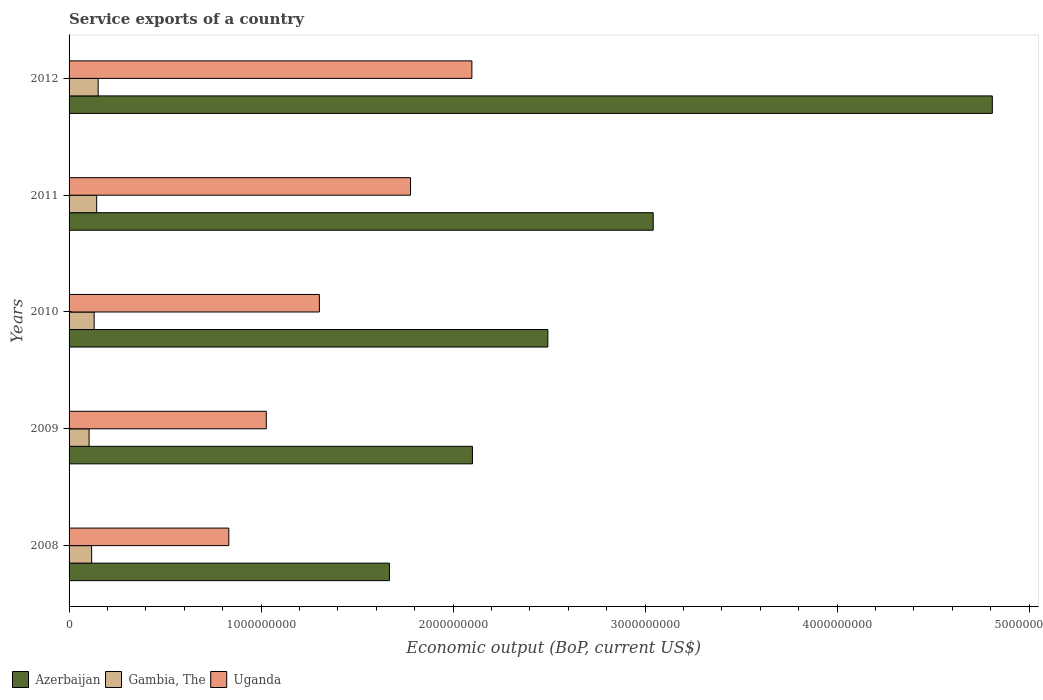How many groups of bars are there?
Provide a short and direct response. 5. Are the number of bars per tick equal to the number of legend labels?
Provide a short and direct response. Yes. Are the number of bars on each tick of the Y-axis equal?
Your answer should be compact. Yes. How many bars are there on the 2nd tick from the bottom?
Your answer should be very brief. 3. In how many cases, is the number of bars for a given year not equal to the number of legend labels?
Your answer should be very brief. 0. What is the service exports in Uganda in 2012?
Keep it short and to the point. 2.10e+09. Across all years, what is the maximum service exports in Uganda?
Provide a succinct answer. 2.10e+09. Across all years, what is the minimum service exports in Uganda?
Your answer should be compact. 8.32e+08. In which year was the service exports in Gambia, The maximum?
Your answer should be very brief. 2012. What is the total service exports in Azerbaijan in the graph?
Provide a succinct answer. 1.41e+1. What is the difference between the service exports in Gambia, The in 2010 and that in 2012?
Offer a very short reply. -2.08e+07. What is the difference between the service exports in Azerbaijan in 2011 and the service exports in Gambia, The in 2008?
Your answer should be very brief. 2.92e+09. What is the average service exports in Azerbaijan per year?
Your response must be concise. 2.82e+09. In the year 2010, what is the difference between the service exports in Gambia, The and service exports in Uganda?
Your response must be concise. -1.17e+09. What is the ratio of the service exports in Gambia, The in 2010 to that in 2012?
Offer a terse response. 0.86. What is the difference between the highest and the second highest service exports in Uganda?
Make the answer very short. 3.20e+08. What is the difference between the highest and the lowest service exports in Azerbaijan?
Give a very brief answer. 3.14e+09. In how many years, is the service exports in Uganda greater than the average service exports in Uganda taken over all years?
Give a very brief answer. 2. Is the sum of the service exports in Gambia, The in 2008 and 2011 greater than the maximum service exports in Azerbaijan across all years?
Offer a very short reply. No. What does the 1st bar from the top in 2009 represents?
Your answer should be very brief. Uganda. What does the 2nd bar from the bottom in 2012 represents?
Give a very brief answer. Gambia, The. How many bars are there?
Offer a very short reply. 15. Are all the bars in the graph horizontal?
Offer a very short reply. Yes. Are the values on the major ticks of X-axis written in scientific E-notation?
Ensure brevity in your answer.  No. Does the graph contain any zero values?
Offer a very short reply. No. How many legend labels are there?
Offer a terse response. 3. How are the legend labels stacked?
Make the answer very short. Horizontal. What is the title of the graph?
Give a very brief answer. Service exports of a country. What is the label or title of the X-axis?
Offer a very short reply. Economic output (BoP, current US$). What is the Economic output (BoP, current US$) of Azerbaijan in 2008?
Give a very brief answer. 1.67e+09. What is the Economic output (BoP, current US$) in Gambia, The in 2008?
Provide a succinct answer. 1.18e+08. What is the Economic output (BoP, current US$) of Uganda in 2008?
Offer a terse response. 8.32e+08. What is the Economic output (BoP, current US$) in Azerbaijan in 2009?
Give a very brief answer. 2.10e+09. What is the Economic output (BoP, current US$) of Gambia, The in 2009?
Keep it short and to the point. 1.04e+08. What is the Economic output (BoP, current US$) of Uganda in 2009?
Provide a succinct answer. 1.03e+09. What is the Economic output (BoP, current US$) of Azerbaijan in 2010?
Keep it short and to the point. 2.49e+09. What is the Economic output (BoP, current US$) in Gambia, The in 2010?
Keep it short and to the point. 1.31e+08. What is the Economic output (BoP, current US$) of Uganda in 2010?
Keep it short and to the point. 1.30e+09. What is the Economic output (BoP, current US$) of Azerbaijan in 2011?
Your response must be concise. 3.04e+09. What is the Economic output (BoP, current US$) in Gambia, The in 2011?
Give a very brief answer. 1.44e+08. What is the Economic output (BoP, current US$) in Uganda in 2011?
Offer a very short reply. 1.78e+09. What is the Economic output (BoP, current US$) of Azerbaijan in 2012?
Offer a terse response. 4.81e+09. What is the Economic output (BoP, current US$) of Gambia, The in 2012?
Make the answer very short. 1.51e+08. What is the Economic output (BoP, current US$) of Uganda in 2012?
Make the answer very short. 2.10e+09. Across all years, what is the maximum Economic output (BoP, current US$) of Azerbaijan?
Ensure brevity in your answer.  4.81e+09. Across all years, what is the maximum Economic output (BoP, current US$) of Gambia, The?
Offer a very short reply. 1.51e+08. Across all years, what is the maximum Economic output (BoP, current US$) of Uganda?
Make the answer very short. 2.10e+09. Across all years, what is the minimum Economic output (BoP, current US$) of Azerbaijan?
Your answer should be compact. 1.67e+09. Across all years, what is the minimum Economic output (BoP, current US$) of Gambia, The?
Provide a short and direct response. 1.04e+08. Across all years, what is the minimum Economic output (BoP, current US$) in Uganda?
Your answer should be compact. 8.32e+08. What is the total Economic output (BoP, current US$) in Azerbaijan in the graph?
Offer a terse response. 1.41e+1. What is the total Economic output (BoP, current US$) of Gambia, The in the graph?
Keep it short and to the point. 6.48e+08. What is the total Economic output (BoP, current US$) in Uganda in the graph?
Your answer should be compact. 7.04e+09. What is the difference between the Economic output (BoP, current US$) of Azerbaijan in 2008 and that in 2009?
Provide a succinct answer. -4.32e+08. What is the difference between the Economic output (BoP, current US$) of Gambia, The in 2008 and that in 2009?
Ensure brevity in your answer.  1.34e+07. What is the difference between the Economic output (BoP, current US$) in Uganda in 2008 and that in 2009?
Provide a succinct answer. -1.95e+08. What is the difference between the Economic output (BoP, current US$) of Azerbaijan in 2008 and that in 2010?
Give a very brief answer. -8.25e+08. What is the difference between the Economic output (BoP, current US$) of Gambia, The in 2008 and that in 2010?
Make the answer very short. -1.31e+07. What is the difference between the Economic output (BoP, current US$) in Uganda in 2008 and that in 2010?
Provide a short and direct response. -4.72e+08. What is the difference between the Economic output (BoP, current US$) of Azerbaijan in 2008 and that in 2011?
Ensure brevity in your answer.  -1.37e+09. What is the difference between the Economic output (BoP, current US$) of Gambia, The in 2008 and that in 2011?
Ensure brevity in your answer.  -2.62e+07. What is the difference between the Economic output (BoP, current US$) of Uganda in 2008 and that in 2011?
Offer a very short reply. -9.46e+08. What is the difference between the Economic output (BoP, current US$) in Azerbaijan in 2008 and that in 2012?
Give a very brief answer. -3.14e+09. What is the difference between the Economic output (BoP, current US$) of Gambia, The in 2008 and that in 2012?
Keep it short and to the point. -3.39e+07. What is the difference between the Economic output (BoP, current US$) in Uganda in 2008 and that in 2012?
Make the answer very short. -1.27e+09. What is the difference between the Economic output (BoP, current US$) in Azerbaijan in 2009 and that in 2010?
Give a very brief answer. -3.93e+08. What is the difference between the Economic output (BoP, current US$) of Gambia, The in 2009 and that in 2010?
Offer a very short reply. -2.65e+07. What is the difference between the Economic output (BoP, current US$) of Uganda in 2009 and that in 2010?
Make the answer very short. -2.76e+08. What is the difference between the Economic output (BoP, current US$) in Azerbaijan in 2009 and that in 2011?
Keep it short and to the point. -9.42e+08. What is the difference between the Economic output (BoP, current US$) of Gambia, The in 2009 and that in 2011?
Give a very brief answer. -3.95e+07. What is the difference between the Economic output (BoP, current US$) in Uganda in 2009 and that in 2011?
Your response must be concise. -7.51e+08. What is the difference between the Economic output (BoP, current US$) of Azerbaijan in 2009 and that in 2012?
Give a very brief answer. -2.71e+09. What is the difference between the Economic output (BoP, current US$) of Gambia, The in 2009 and that in 2012?
Give a very brief answer. -4.73e+07. What is the difference between the Economic output (BoP, current US$) of Uganda in 2009 and that in 2012?
Provide a short and direct response. -1.07e+09. What is the difference between the Economic output (BoP, current US$) in Azerbaijan in 2010 and that in 2011?
Offer a terse response. -5.49e+08. What is the difference between the Economic output (BoP, current US$) in Gambia, The in 2010 and that in 2011?
Provide a short and direct response. -1.31e+07. What is the difference between the Economic output (BoP, current US$) of Uganda in 2010 and that in 2011?
Keep it short and to the point. -4.75e+08. What is the difference between the Economic output (BoP, current US$) of Azerbaijan in 2010 and that in 2012?
Ensure brevity in your answer.  -2.32e+09. What is the difference between the Economic output (BoP, current US$) in Gambia, The in 2010 and that in 2012?
Ensure brevity in your answer.  -2.08e+07. What is the difference between the Economic output (BoP, current US$) of Uganda in 2010 and that in 2012?
Provide a short and direct response. -7.94e+08. What is the difference between the Economic output (BoP, current US$) of Azerbaijan in 2011 and that in 2012?
Your answer should be compact. -1.77e+09. What is the difference between the Economic output (BoP, current US$) of Gambia, The in 2011 and that in 2012?
Ensure brevity in your answer.  -7.74e+06. What is the difference between the Economic output (BoP, current US$) of Uganda in 2011 and that in 2012?
Your response must be concise. -3.20e+08. What is the difference between the Economic output (BoP, current US$) of Azerbaijan in 2008 and the Economic output (BoP, current US$) of Gambia, The in 2009?
Make the answer very short. 1.56e+09. What is the difference between the Economic output (BoP, current US$) of Azerbaijan in 2008 and the Economic output (BoP, current US$) of Uganda in 2009?
Make the answer very short. 6.41e+08. What is the difference between the Economic output (BoP, current US$) in Gambia, The in 2008 and the Economic output (BoP, current US$) in Uganda in 2009?
Give a very brief answer. -9.10e+08. What is the difference between the Economic output (BoP, current US$) of Azerbaijan in 2008 and the Economic output (BoP, current US$) of Gambia, The in 2010?
Provide a short and direct response. 1.54e+09. What is the difference between the Economic output (BoP, current US$) of Azerbaijan in 2008 and the Economic output (BoP, current US$) of Uganda in 2010?
Keep it short and to the point. 3.65e+08. What is the difference between the Economic output (BoP, current US$) of Gambia, The in 2008 and the Economic output (BoP, current US$) of Uganda in 2010?
Your answer should be compact. -1.19e+09. What is the difference between the Economic output (BoP, current US$) in Azerbaijan in 2008 and the Economic output (BoP, current US$) in Gambia, The in 2011?
Your answer should be compact. 1.52e+09. What is the difference between the Economic output (BoP, current US$) in Azerbaijan in 2008 and the Economic output (BoP, current US$) in Uganda in 2011?
Offer a very short reply. -1.10e+08. What is the difference between the Economic output (BoP, current US$) in Gambia, The in 2008 and the Economic output (BoP, current US$) in Uganda in 2011?
Provide a succinct answer. -1.66e+09. What is the difference between the Economic output (BoP, current US$) of Azerbaijan in 2008 and the Economic output (BoP, current US$) of Gambia, The in 2012?
Provide a short and direct response. 1.52e+09. What is the difference between the Economic output (BoP, current US$) of Azerbaijan in 2008 and the Economic output (BoP, current US$) of Uganda in 2012?
Give a very brief answer. -4.29e+08. What is the difference between the Economic output (BoP, current US$) in Gambia, The in 2008 and the Economic output (BoP, current US$) in Uganda in 2012?
Ensure brevity in your answer.  -1.98e+09. What is the difference between the Economic output (BoP, current US$) of Azerbaijan in 2009 and the Economic output (BoP, current US$) of Gambia, The in 2010?
Make the answer very short. 1.97e+09. What is the difference between the Economic output (BoP, current US$) in Azerbaijan in 2009 and the Economic output (BoP, current US$) in Uganda in 2010?
Offer a terse response. 7.97e+08. What is the difference between the Economic output (BoP, current US$) in Gambia, The in 2009 and the Economic output (BoP, current US$) in Uganda in 2010?
Your answer should be very brief. -1.20e+09. What is the difference between the Economic output (BoP, current US$) in Azerbaijan in 2009 and the Economic output (BoP, current US$) in Gambia, The in 2011?
Provide a succinct answer. 1.96e+09. What is the difference between the Economic output (BoP, current US$) of Azerbaijan in 2009 and the Economic output (BoP, current US$) of Uganda in 2011?
Give a very brief answer. 3.23e+08. What is the difference between the Economic output (BoP, current US$) of Gambia, The in 2009 and the Economic output (BoP, current US$) of Uganda in 2011?
Provide a short and direct response. -1.67e+09. What is the difference between the Economic output (BoP, current US$) of Azerbaijan in 2009 and the Economic output (BoP, current US$) of Gambia, The in 2012?
Offer a terse response. 1.95e+09. What is the difference between the Economic output (BoP, current US$) in Azerbaijan in 2009 and the Economic output (BoP, current US$) in Uganda in 2012?
Your response must be concise. 2.95e+06. What is the difference between the Economic output (BoP, current US$) of Gambia, The in 2009 and the Economic output (BoP, current US$) of Uganda in 2012?
Provide a succinct answer. -1.99e+09. What is the difference between the Economic output (BoP, current US$) in Azerbaijan in 2010 and the Economic output (BoP, current US$) in Gambia, The in 2011?
Offer a terse response. 2.35e+09. What is the difference between the Economic output (BoP, current US$) of Azerbaijan in 2010 and the Economic output (BoP, current US$) of Uganda in 2011?
Offer a very short reply. 7.15e+08. What is the difference between the Economic output (BoP, current US$) in Gambia, The in 2010 and the Economic output (BoP, current US$) in Uganda in 2011?
Your answer should be very brief. -1.65e+09. What is the difference between the Economic output (BoP, current US$) in Azerbaijan in 2010 and the Economic output (BoP, current US$) in Gambia, The in 2012?
Provide a short and direct response. 2.34e+09. What is the difference between the Economic output (BoP, current US$) in Azerbaijan in 2010 and the Economic output (BoP, current US$) in Uganda in 2012?
Offer a terse response. 3.96e+08. What is the difference between the Economic output (BoP, current US$) of Gambia, The in 2010 and the Economic output (BoP, current US$) of Uganda in 2012?
Provide a short and direct response. -1.97e+09. What is the difference between the Economic output (BoP, current US$) of Azerbaijan in 2011 and the Economic output (BoP, current US$) of Gambia, The in 2012?
Your response must be concise. 2.89e+09. What is the difference between the Economic output (BoP, current US$) in Azerbaijan in 2011 and the Economic output (BoP, current US$) in Uganda in 2012?
Give a very brief answer. 9.45e+08. What is the difference between the Economic output (BoP, current US$) of Gambia, The in 2011 and the Economic output (BoP, current US$) of Uganda in 2012?
Your answer should be very brief. -1.95e+09. What is the average Economic output (BoP, current US$) of Azerbaijan per year?
Offer a terse response. 2.82e+09. What is the average Economic output (BoP, current US$) of Gambia, The per year?
Give a very brief answer. 1.30e+08. What is the average Economic output (BoP, current US$) of Uganda per year?
Keep it short and to the point. 1.41e+09. In the year 2008, what is the difference between the Economic output (BoP, current US$) of Azerbaijan and Economic output (BoP, current US$) of Gambia, The?
Your answer should be very brief. 1.55e+09. In the year 2008, what is the difference between the Economic output (BoP, current US$) of Azerbaijan and Economic output (BoP, current US$) of Uganda?
Offer a very short reply. 8.36e+08. In the year 2008, what is the difference between the Economic output (BoP, current US$) in Gambia, The and Economic output (BoP, current US$) in Uganda?
Offer a terse response. -7.15e+08. In the year 2009, what is the difference between the Economic output (BoP, current US$) of Azerbaijan and Economic output (BoP, current US$) of Gambia, The?
Give a very brief answer. 2.00e+09. In the year 2009, what is the difference between the Economic output (BoP, current US$) in Azerbaijan and Economic output (BoP, current US$) in Uganda?
Make the answer very short. 1.07e+09. In the year 2009, what is the difference between the Economic output (BoP, current US$) of Gambia, The and Economic output (BoP, current US$) of Uganda?
Ensure brevity in your answer.  -9.23e+08. In the year 2010, what is the difference between the Economic output (BoP, current US$) of Azerbaijan and Economic output (BoP, current US$) of Gambia, The?
Your answer should be compact. 2.36e+09. In the year 2010, what is the difference between the Economic output (BoP, current US$) of Azerbaijan and Economic output (BoP, current US$) of Uganda?
Your answer should be compact. 1.19e+09. In the year 2010, what is the difference between the Economic output (BoP, current US$) in Gambia, The and Economic output (BoP, current US$) in Uganda?
Your response must be concise. -1.17e+09. In the year 2011, what is the difference between the Economic output (BoP, current US$) of Azerbaijan and Economic output (BoP, current US$) of Gambia, The?
Make the answer very short. 2.90e+09. In the year 2011, what is the difference between the Economic output (BoP, current US$) in Azerbaijan and Economic output (BoP, current US$) in Uganda?
Provide a short and direct response. 1.26e+09. In the year 2011, what is the difference between the Economic output (BoP, current US$) in Gambia, The and Economic output (BoP, current US$) in Uganda?
Give a very brief answer. -1.63e+09. In the year 2012, what is the difference between the Economic output (BoP, current US$) in Azerbaijan and Economic output (BoP, current US$) in Gambia, The?
Your answer should be very brief. 4.66e+09. In the year 2012, what is the difference between the Economic output (BoP, current US$) of Azerbaijan and Economic output (BoP, current US$) of Uganda?
Give a very brief answer. 2.71e+09. In the year 2012, what is the difference between the Economic output (BoP, current US$) in Gambia, The and Economic output (BoP, current US$) in Uganda?
Ensure brevity in your answer.  -1.95e+09. What is the ratio of the Economic output (BoP, current US$) of Azerbaijan in 2008 to that in 2009?
Your answer should be compact. 0.79. What is the ratio of the Economic output (BoP, current US$) in Gambia, The in 2008 to that in 2009?
Offer a very short reply. 1.13. What is the ratio of the Economic output (BoP, current US$) of Uganda in 2008 to that in 2009?
Make the answer very short. 0.81. What is the ratio of the Economic output (BoP, current US$) in Azerbaijan in 2008 to that in 2010?
Your answer should be compact. 0.67. What is the ratio of the Economic output (BoP, current US$) in Gambia, The in 2008 to that in 2010?
Give a very brief answer. 0.9. What is the ratio of the Economic output (BoP, current US$) in Uganda in 2008 to that in 2010?
Ensure brevity in your answer.  0.64. What is the ratio of the Economic output (BoP, current US$) of Azerbaijan in 2008 to that in 2011?
Offer a terse response. 0.55. What is the ratio of the Economic output (BoP, current US$) of Gambia, The in 2008 to that in 2011?
Your response must be concise. 0.82. What is the ratio of the Economic output (BoP, current US$) of Uganda in 2008 to that in 2011?
Provide a succinct answer. 0.47. What is the ratio of the Economic output (BoP, current US$) in Azerbaijan in 2008 to that in 2012?
Your answer should be compact. 0.35. What is the ratio of the Economic output (BoP, current US$) in Gambia, The in 2008 to that in 2012?
Give a very brief answer. 0.78. What is the ratio of the Economic output (BoP, current US$) in Uganda in 2008 to that in 2012?
Provide a succinct answer. 0.4. What is the ratio of the Economic output (BoP, current US$) in Azerbaijan in 2009 to that in 2010?
Make the answer very short. 0.84. What is the ratio of the Economic output (BoP, current US$) of Gambia, The in 2009 to that in 2010?
Make the answer very short. 0.8. What is the ratio of the Economic output (BoP, current US$) of Uganda in 2009 to that in 2010?
Provide a succinct answer. 0.79. What is the ratio of the Economic output (BoP, current US$) of Azerbaijan in 2009 to that in 2011?
Provide a succinct answer. 0.69. What is the ratio of the Economic output (BoP, current US$) of Gambia, The in 2009 to that in 2011?
Provide a short and direct response. 0.72. What is the ratio of the Economic output (BoP, current US$) of Uganda in 2009 to that in 2011?
Your answer should be compact. 0.58. What is the ratio of the Economic output (BoP, current US$) in Azerbaijan in 2009 to that in 2012?
Your answer should be compact. 0.44. What is the ratio of the Economic output (BoP, current US$) in Gambia, The in 2009 to that in 2012?
Your answer should be compact. 0.69. What is the ratio of the Economic output (BoP, current US$) in Uganda in 2009 to that in 2012?
Offer a terse response. 0.49. What is the ratio of the Economic output (BoP, current US$) in Azerbaijan in 2010 to that in 2011?
Your response must be concise. 0.82. What is the ratio of the Economic output (BoP, current US$) in Gambia, The in 2010 to that in 2011?
Your response must be concise. 0.91. What is the ratio of the Economic output (BoP, current US$) of Uganda in 2010 to that in 2011?
Make the answer very short. 0.73. What is the ratio of the Economic output (BoP, current US$) in Azerbaijan in 2010 to that in 2012?
Offer a very short reply. 0.52. What is the ratio of the Economic output (BoP, current US$) in Gambia, The in 2010 to that in 2012?
Keep it short and to the point. 0.86. What is the ratio of the Economic output (BoP, current US$) of Uganda in 2010 to that in 2012?
Give a very brief answer. 0.62. What is the ratio of the Economic output (BoP, current US$) of Azerbaijan in 2011 to that in 2012?
Offer a very short reply. 0.63. What is the ratio of the Economic output (BoP, current US$) in Gambia, The in 2011 to that in 2012?
Your answer should be very brief. 0.95. What is the ratio of the Economic output (BoP, current US$) in Uganda in 2011 to that in 2012?
Offer a terse response. 0.85. What is the difference between the highest and the second highest Economic output (BoP, current US$) in Azerbaijan?
Your answer should be compact. 1.77e+09. What is the difference between the highest and the second highest Economic output (BoP, current US$) in Gambia, The?
Ensure brevity in your answer.  7.74e+06. What is the difference between the highest and the second highest Economic output (BoP, current US$) of Uganda?
Ensure brevity in your answer.  3.20e+08. What is the difference between the highest and the lowest Economic output (BoP, current US$) in Azerbaijan?
Keep it short and to the point. 3.14e+09. What is the difference between the highest and the lowest Economic output (BoP, current US$) in Gambia, The?
Your answer should be very brief. 4.73e+07. What is the difference between the highest and the lowest Economic output (BoP, current US$) in Uganda?
Your answer should be compact. 1.27e+09. 